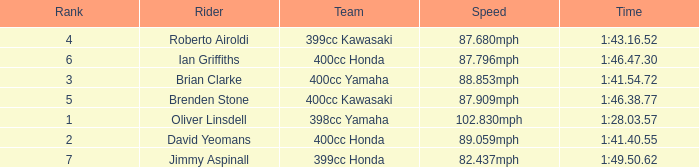What is the time of the rider ranked 6? 1:46.47.30. 